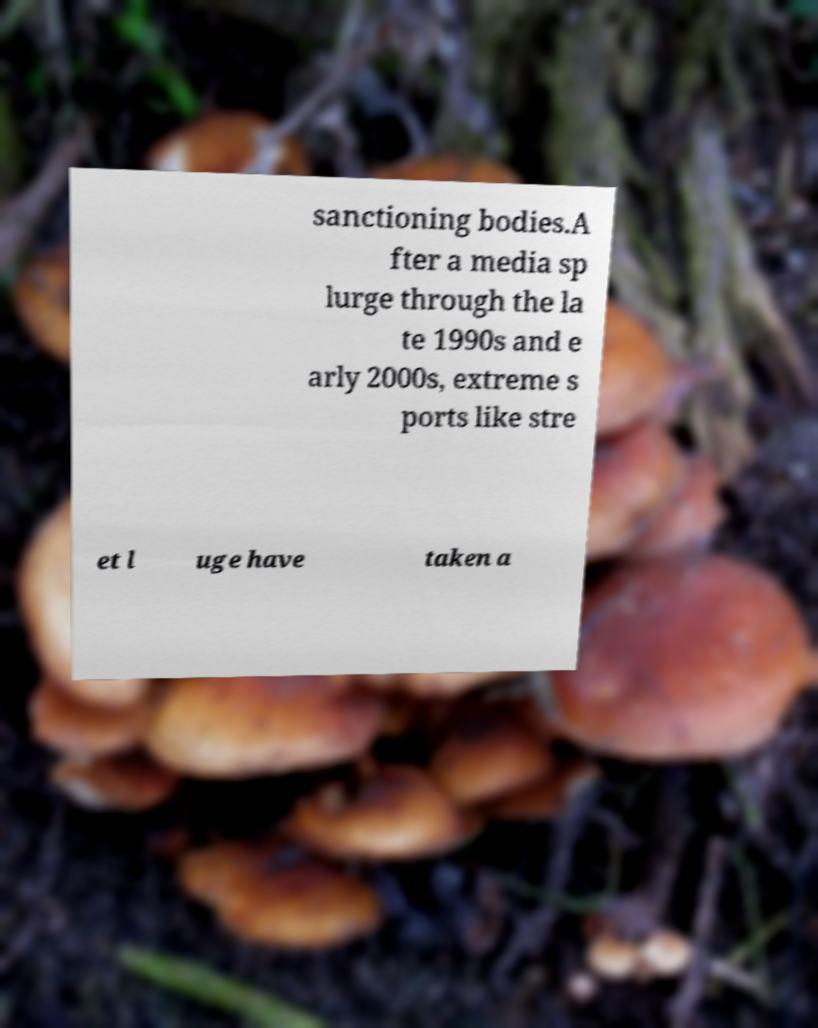Can you accurately transcribe the text from the provided image for me? sanctioning bodies.A fter a media sp lurge through the la te 1990s and e arly 2000s, extreme s ports like stre et l uge have taken a 